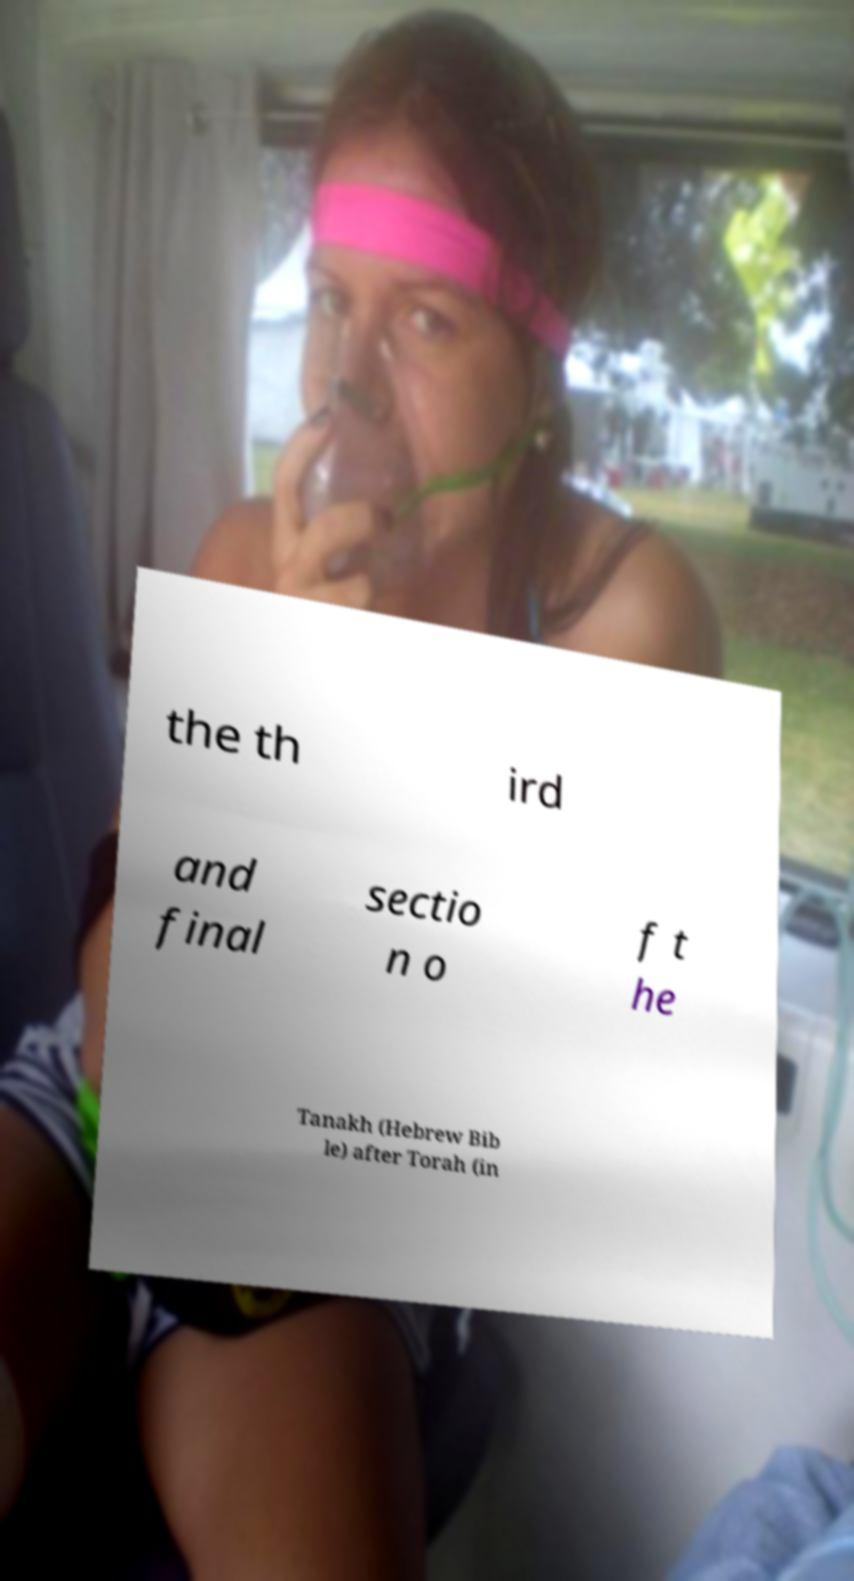Please read and relay the text visible in this image. What does it say? the th ird and final sectio n o f t he Tanakh (Hebrew Bib le) after Torah (in 